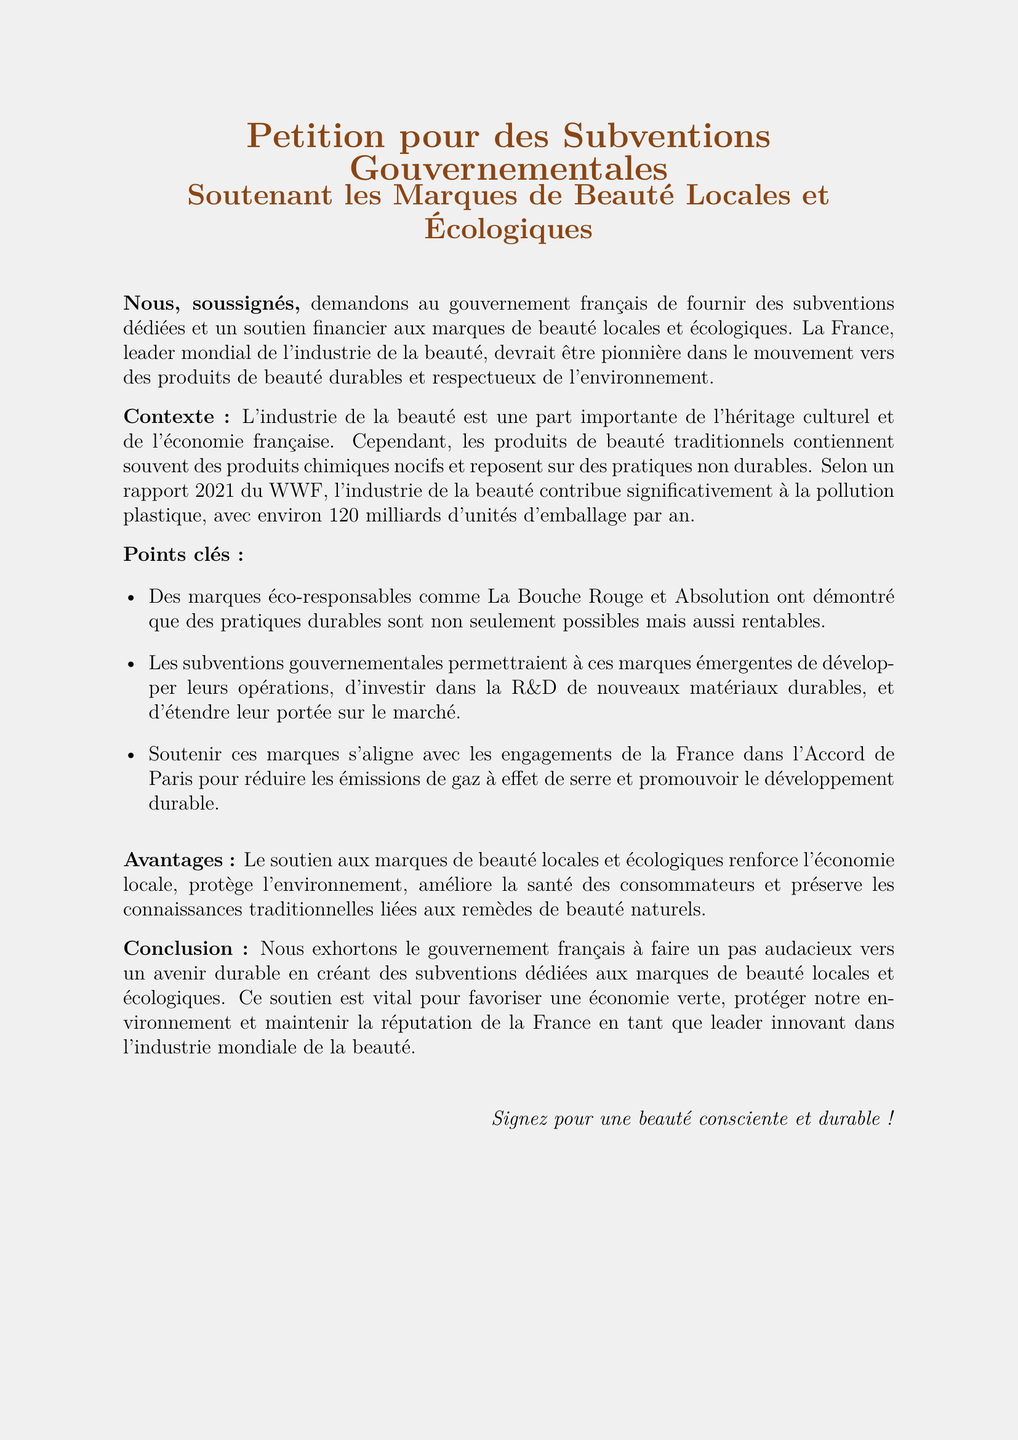What is the title of the petition? The title of the petition is located at the top of the document, clearly stated as "Petition pour des Subventions Gouvernementales".
Answer: Petition pour des Subventions Gouvernementales What are the brands mentioned as eco-responsables? The brands mentioned as eco-responsables in the petition are provided in the key points section.
Answer: La Bouche Rouge et Absolution How many units of packaging does the beauty industry contribute annually? The document states a specific figure regarding annual packaging contributions in the context.
Answer: 120 milliards What is the main purpose of the petition? The main purpose of the petition is outlined early in the document, describing the intention behind it.
Answer: Subventions dédiées et un soutien financier Which international agreement aligns with the support for local eco-friendly brands? The international agreement mentioned that aligns with these actions is specified in a key point of the petition.
Answer: Accord de Paris What environmental issue is highlighted in the petition? The petition discusses a significant environmental issue that is affecting the beauty industry and is highlighted in the context.
Answer: Pollution plastique How do government grants benefit local eco-friendly beauty brands? The benefits of government grants are outlined in the points key section, detailing their impact on operations and development.
Answer: Développer leurs opérations What cultural aspect is mentioned in relation to the beauty industry in France? The cultural aspect of the beauty industry mentioned is describing its significance to France's heritage and economy.
Answer: Héritage culturel What are the consumers’ health benefits mentioned in the petition? The health benefits of supporting local eco-friendly brands are elaborated upon in the advantages section.
Answer: Améliore la santé des consommateurs 